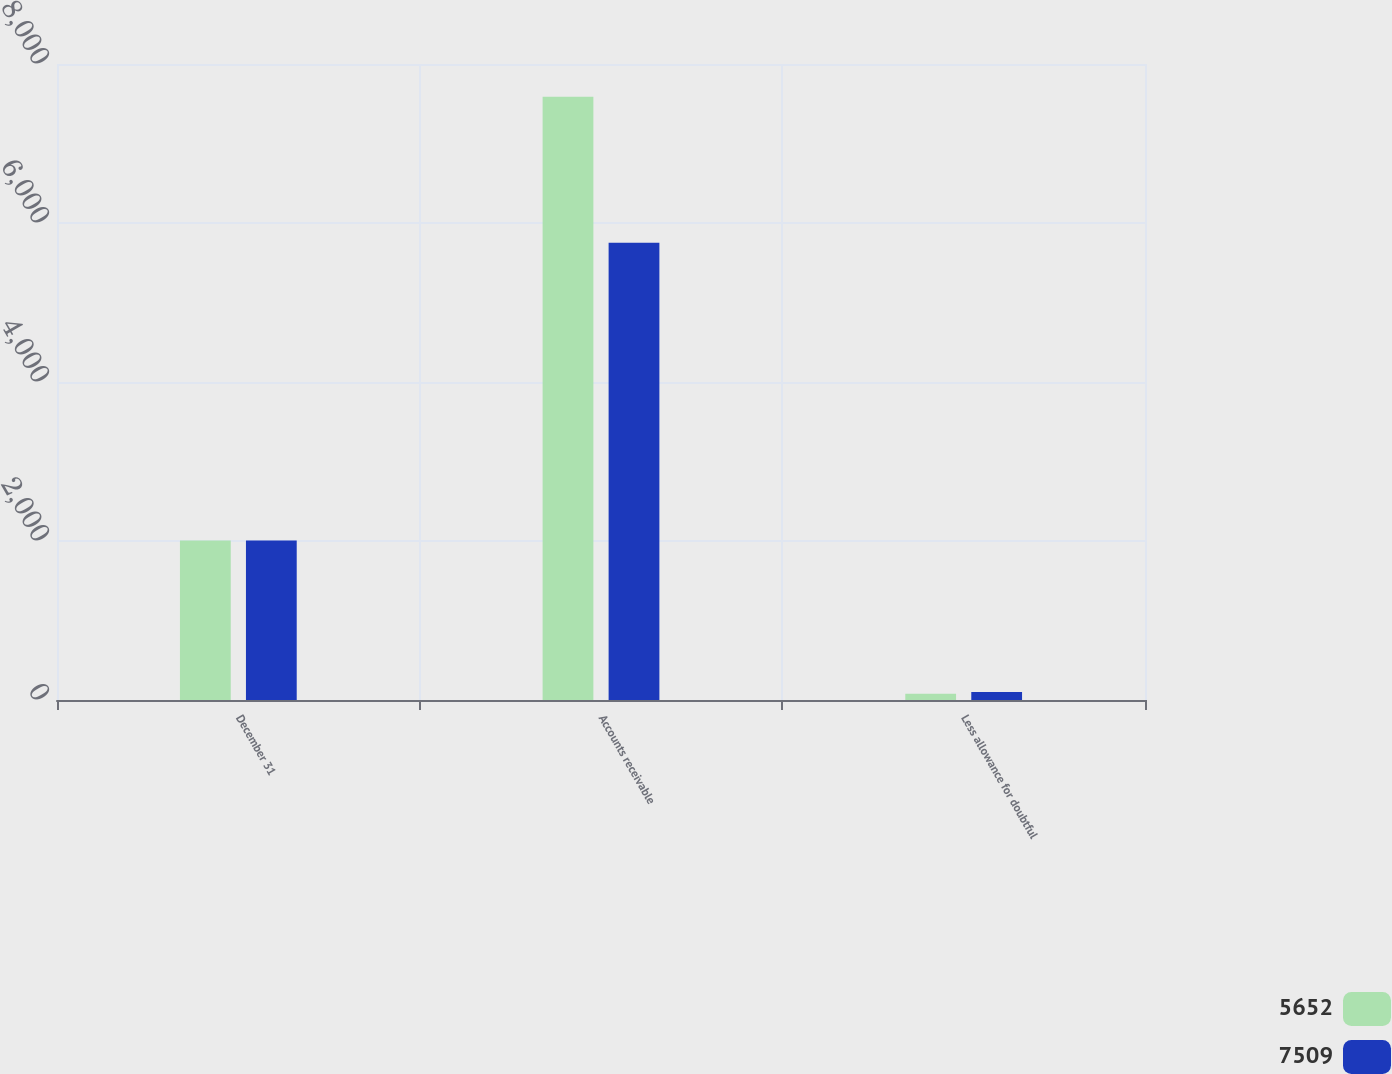Convert chart to OTSL. <chart><loc_0><loc_0><loc_500><loc_500><stacked_bar_chart><ecel><fcel>December 31<fcel>Accounts receivable<fcel>Less allowance for doubtful<nl><fcel>5652<fcel>2006<fcel>7587<fcel>78<nl><fcel>7509<fcel>2005<fcel>5753<fcel>101<nl></chart> 